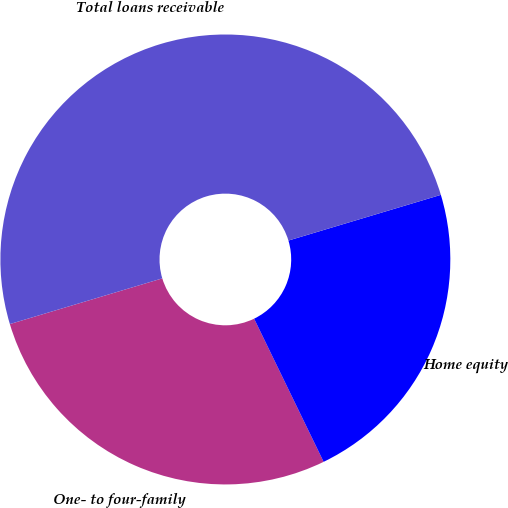Convert chart. <chart><loc_0><loc_0><loc_500><loc_500><pie_chart><fcel>One- to four-family<fcel>Home equity<fcel>Total loans receivable<nl><fcel>27.56%<fcel>22.44%<fcel>50.0%<nl></chart> 